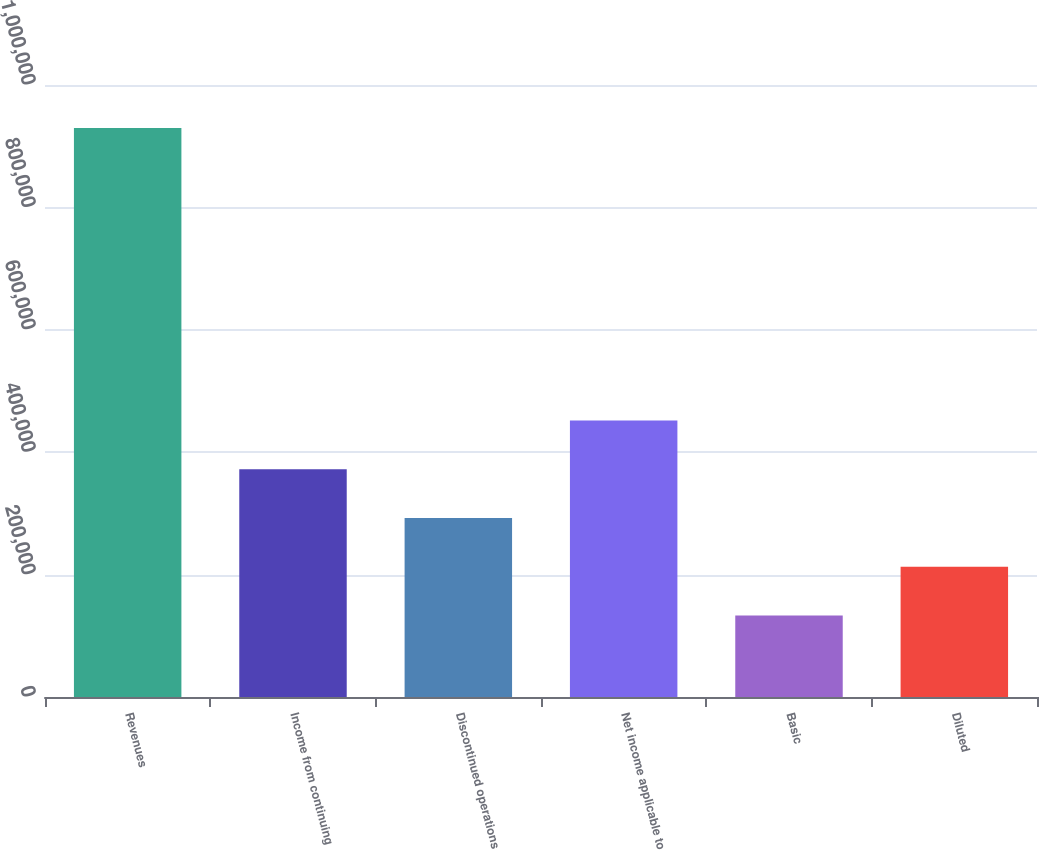Convert chart to OTSL. <chart><loc_0><loc_0><loc_500><loc_500><bar_chart><fcel>Revenues<fcel>Income from continuing<fcel>Discontinued operations<fcel>Net income applicable to<fcel>Basic<fcel>Diluted<nl><fcel>929632<fcel>372088<fcel>292438<fcel>451737<fcel>133140<fcel>212789<nl></chart> 